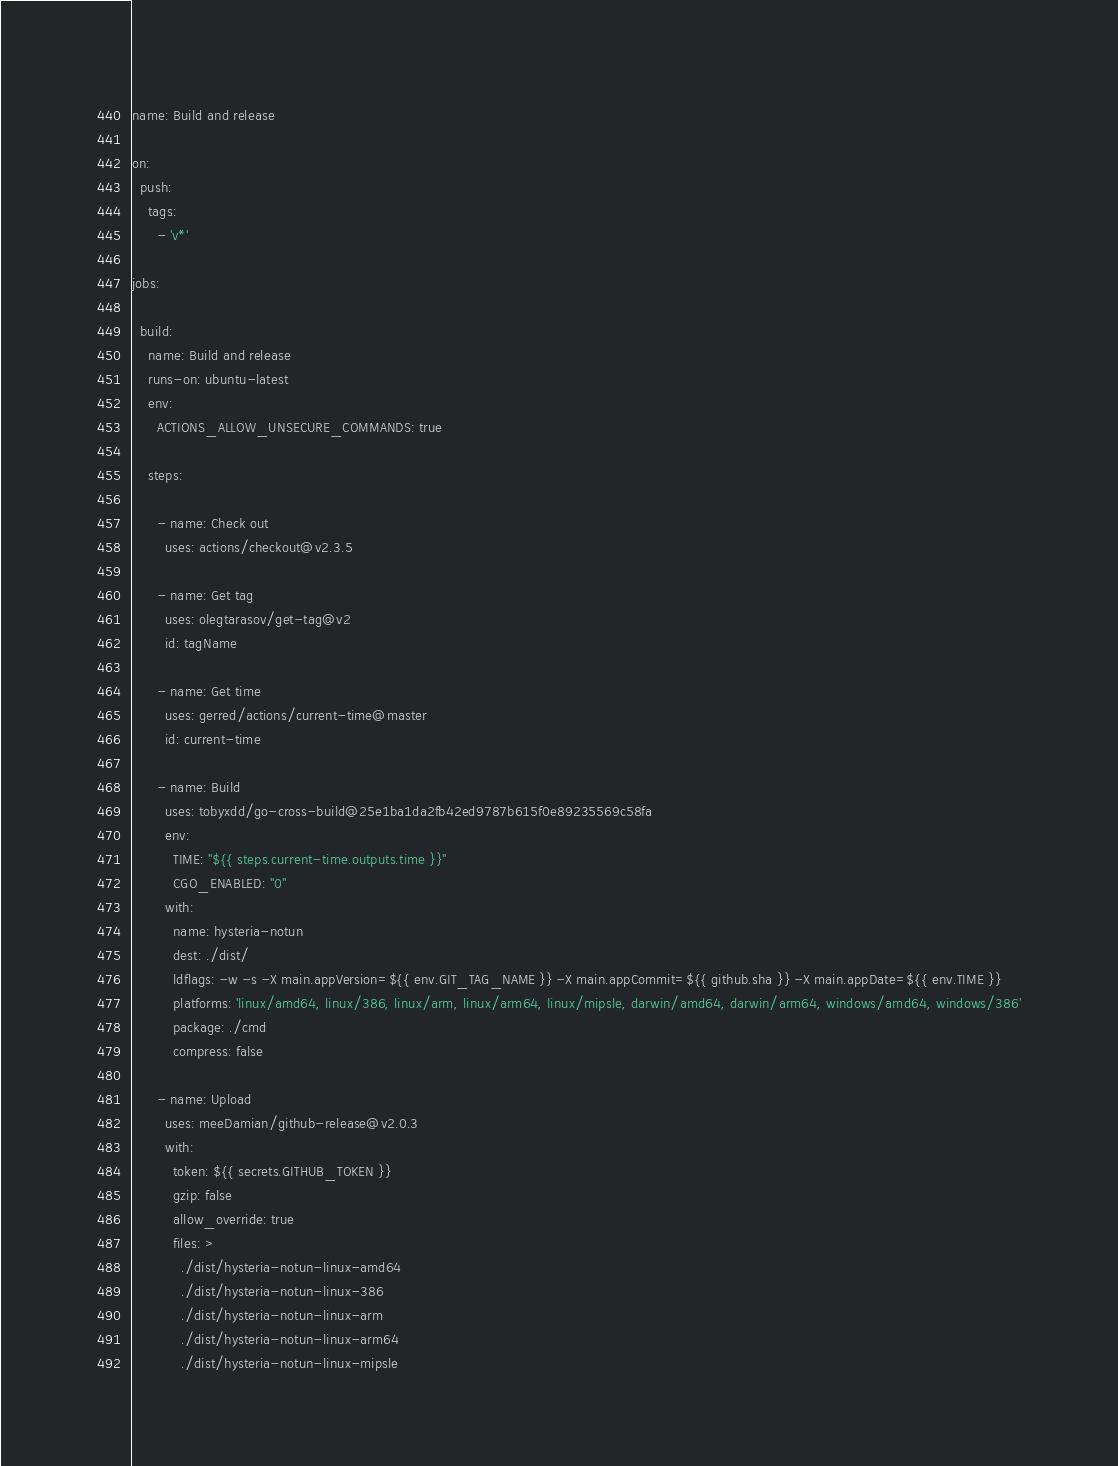<code> <loc_0><loc_0><loc_500><loc_500><_YAML_>name: Build and release

on:
  push:
    tags:
      - 'v*'

jobs:

  build:
    name: Build and release
    runs-on: ubuntu-latest
    env:
      ACTIONS_ALLOW_UNSECURE_COMMANDS: true

    steps:

      - name: Check out
        uses: actions/checkout@v2.3.5

      - name: Get tag
        uses: olegtarasov/get-tag@v2
        id: tagName

      - name: Get time
        uses: gerred/actions/current-time@master
        id: current-time

      - name: Build
        uses: tobyxdd/go-cross-build@25e1ba1da2fb42ed9787b615f0e89235569c58fa
        env:
          TIME: "${{ steps.current-time.outputs.time }}"
          CGO_ENABLED: "0"
        with:
          name: hysteria-notun
          dest: ./dist/
          ldflags: -w -s -X main.appVersion=${{ env.GIT_TAG_NAME }} -X main.appCommit=${{ github.sha }} -X main.appDate=${{ env.TIME }}
          platforms: 'linux/amd64, linux/386, linux/arm, linux/arm64, linux/mipsle, darwin/amd64, darwin/arm64, windows/amd64, windows/386'
          package: ./cmd
          compress: false

      - name: Upload
        uses: meeDamian/github-release@v2.0.3
        with:
          token: ${{ secrets.GITHUB_TOKEN }}
          gzip: false
          allow_override: true
          files: >
            ./dist/hysteria-notun-linux-amd64
            ./dist/hysteria-notun-linux-386
            ./dist/hysteria-notun-linux-arm
            ./dist/hysteria-notun-linux-arm64
            ./dist/hysteria-notun-linux-mipsle
</code> 